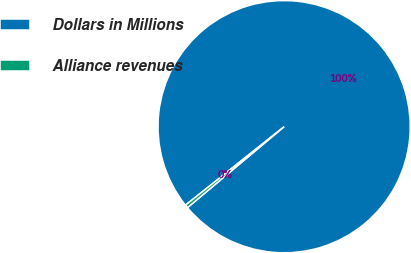Convert chart. <chart><loc_0><loc_0><loc_500><loc_500><pie_chart><fcel>Dollars in Millions<fcel>Alliance revenues<nl><fcel>99.6%<fcel>0.4%<nl></chart> 